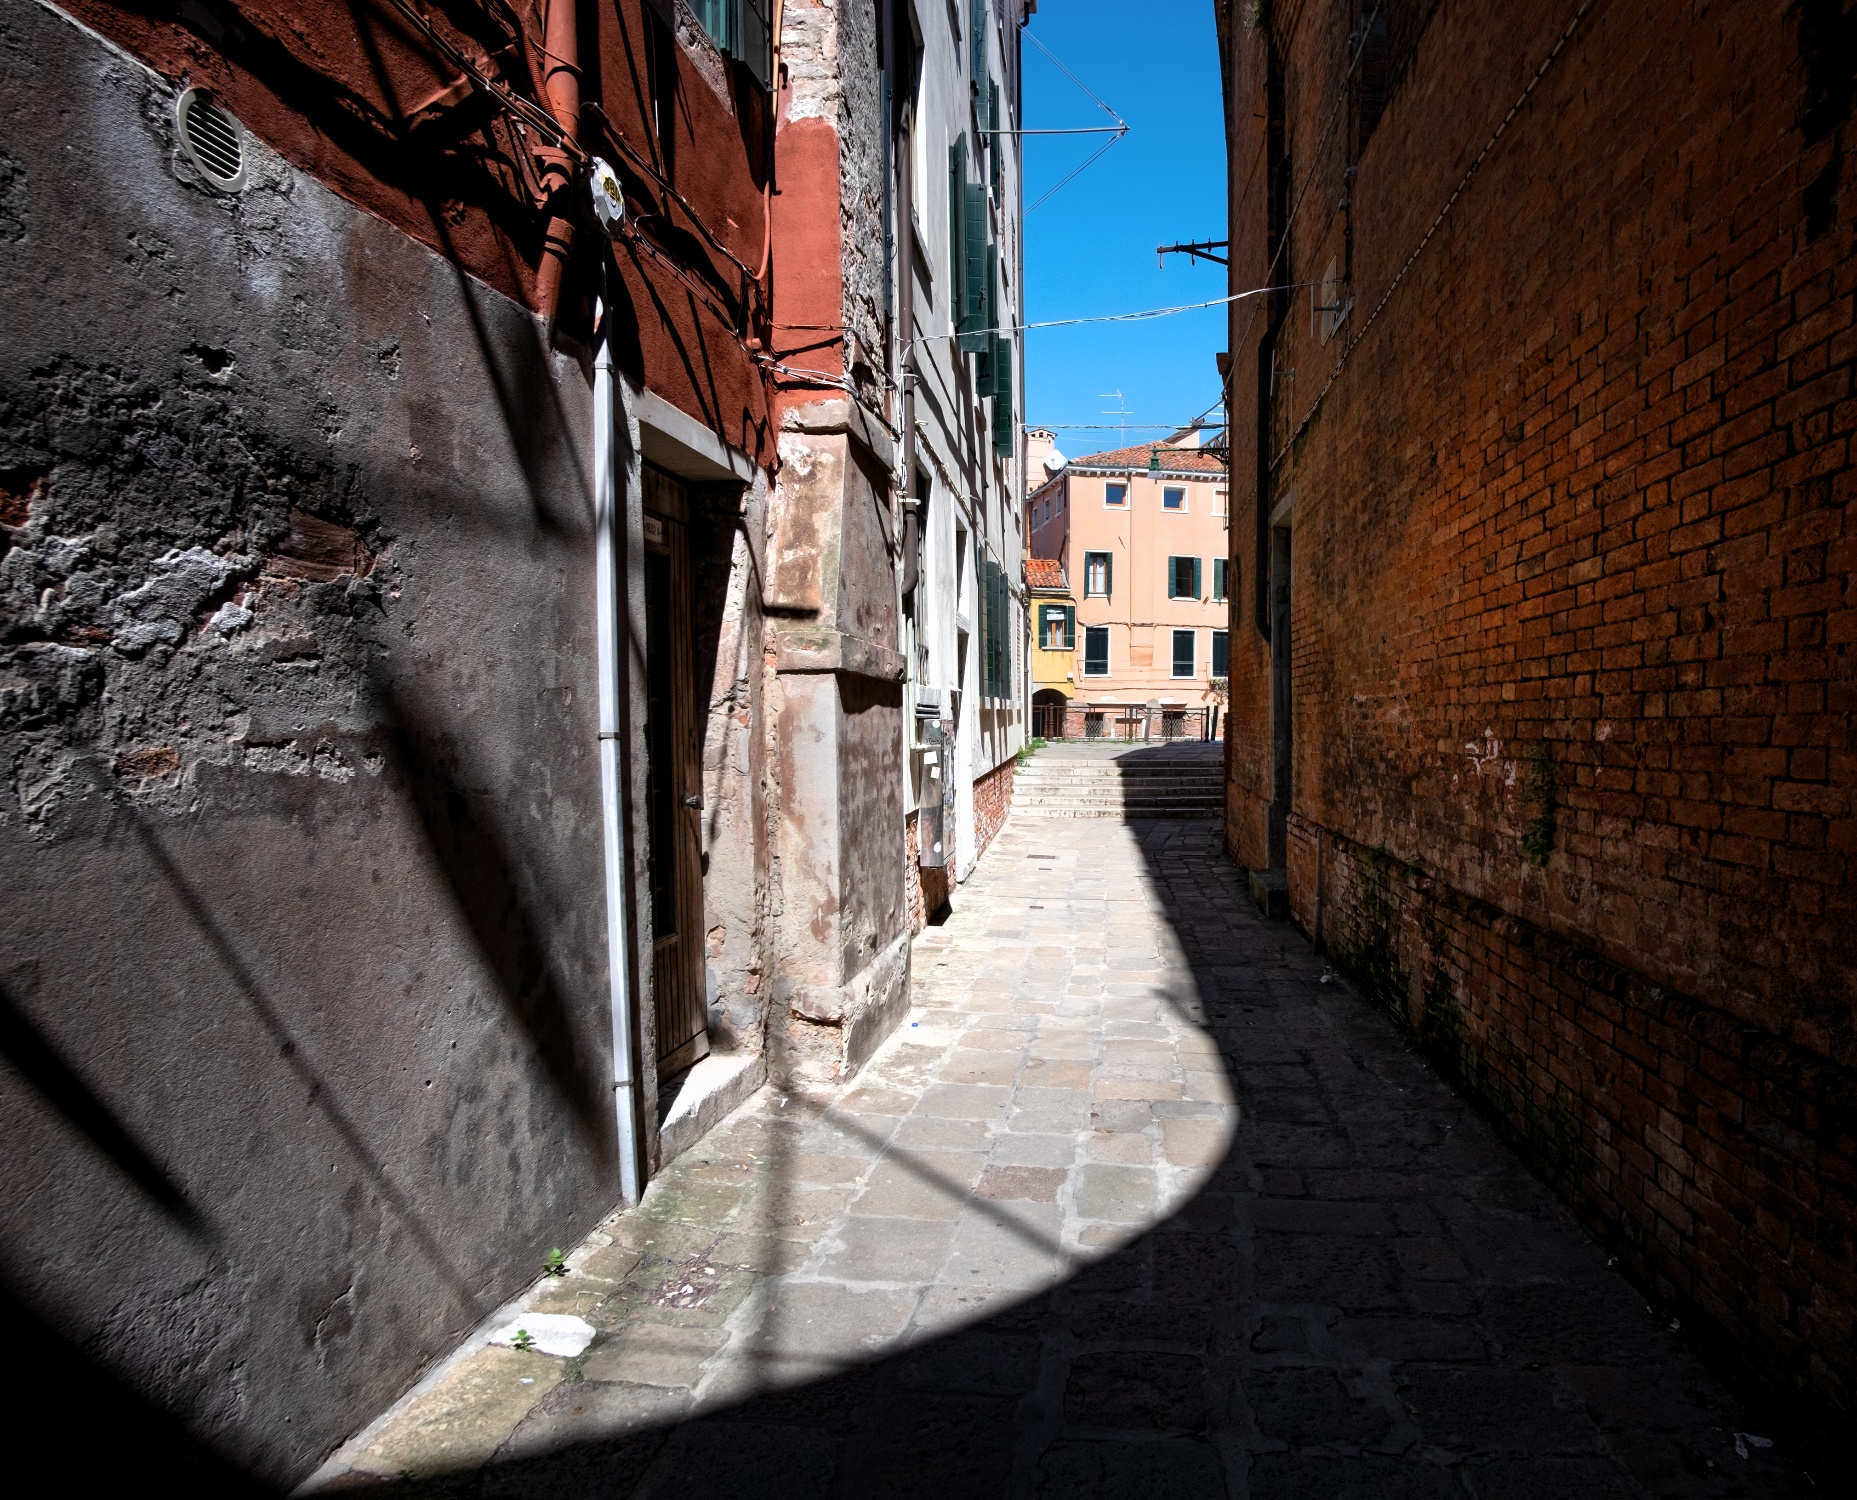What kind of stories might the buildings in this alleyway hold? The buildings in this alleyway could tell countless stories etched into their weathered bricks and stones. They might share tales of families who have lived there for generations, their daily lives interwoven with the history of Venice. Perhaps one building once housed a famous artisan, whose workshop was the birthplace of renowned sculptures or paintings. Another might have been a clandestine meeting spot for revolutionaries or thinkers planning to change the world. The bricks could whisper about love stories, secret affairs conducted in the shadows, or tragic losses during turbulent times such as floods or wars. These buildings could also speak of resilience, embodying the spirit of the community that has adapted and thrived through centuries of change. Each chipped corner and crack might serve as a testament to the passage of time, holding memories of eras gone by. 
Imagine this alleyway at sunrise. How does it look? At sunrise, this alleyway would be bathed in a soft, golden light as the sun begins to rise over Venice. The cobblestones would catch the first rays of the sun, casting warm hues across the street. The shadows from the old brick buildings would be long and gentle, slowly retreating as the light spreads. The colors of the buildings would appear even richer, with the reds and oranges glowing softly in the early morning sunlight. The sky would transition from deep blue to a lighter, pastel shade, possibly adorned with streaks of pink or orange. The alleyway would be quiet, with a peaceful stillness only occasionally interrupted by the distant sounds of early morning activity. It would feel serene and almost magical, as if the alleyway is waking up and greeting a new day with open arms. 